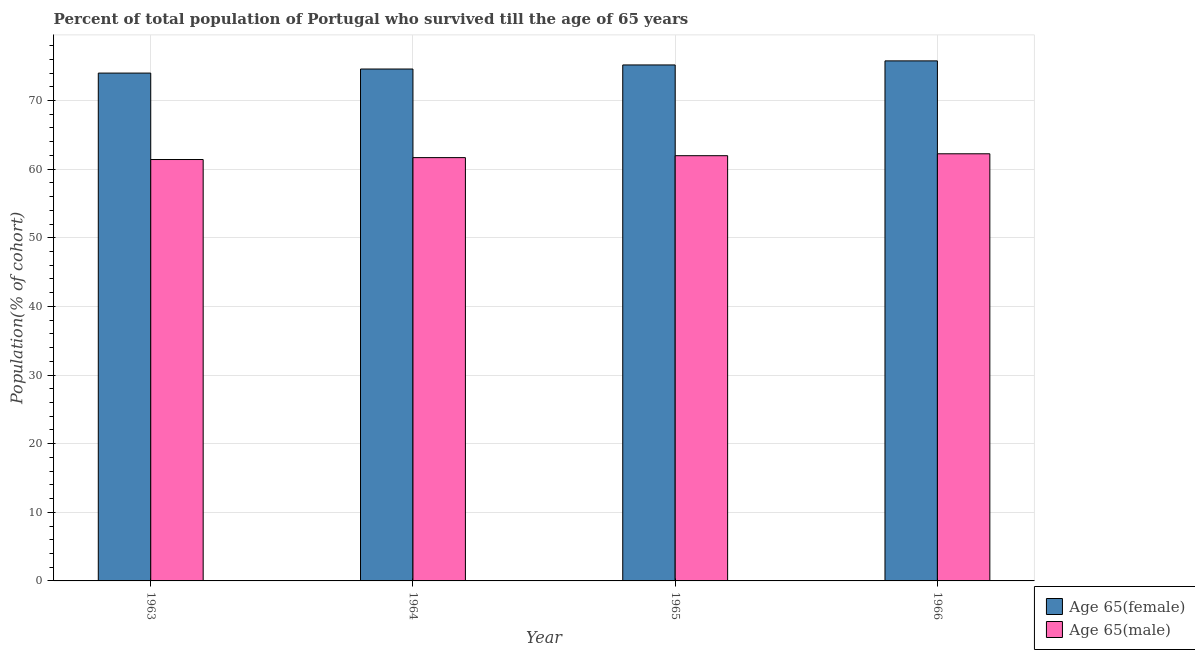How many different coloured bars are there?
Provide a short and direct response. 2. How many groups of bars are there?
Provide a short and direct response. 4. How many bars are there on the 4th tick from the left?
Offer a terse response. 2. How many bars are there on the 4th tick from the right?
Offer a very short reply. 2. What is the label of the 4th group of bars from the left?
Your response must be concise. 1966. In how many cases, is the number of bars for a given year not equal to the number of legend labels?
Offer a very short reply. 0. What is the percentage of male population who survived till age of 65 in 1963?
Ensure brevity in your answer.  61.4. Across all years, what is the maximum percentage of female population who survived till age of 65?
Provide a short and direct response. 75.77. Across all years, what is the minimum percentage of male population who survived till age of 65?
Ensure brevity in your answer.  61.4. In which year was the percentage of female population who survived till age of 65 maximum?
Offer a very short reply. 1966. In which year was the percentage of male population who survived till age of 65 minimum?
Ensure brevity in your answer.  1963. What is the total percentage of female population who survived till age of 65 in the graph?
Make the answer very short. 299.53. What is the difference between the percentage of female population who survived till age of 65 in 1963 and that in 1966?
Your answer should be compact. -1.78. What is the difference between the percentage of female population who survived till age of 65 in 1965 and the percentage of male population who survived till age of 65 in 1964?
Your answer should be compact. 0.59. What is the average percentage of female population who survived till age of 65 per year?
Offer a very short reply. 74.88. What is the ratio of the percentage of male population who survived till age of 65 in 1963 to that in 1966?
Offer a terse response. 0.99. Is the difference between the percentage of female population who survived till age of 65 in 1964 and 1966 greater than the difference between the percentage of male population who survived till age of 65 in 1964 and 1966?
Provide a succinct answer. No. What is the difference between the highest and the second highest percentage of male population who survived till age of 65?
Your answer should be compact. 0.28. What is the difference between the highest and the lowest percentage of female population who survived till age of 65?
Make the answer very short. 1.78. Is the sum of the percentage of female population who survived till age of 65 in 1963 and 1965 greater than the maximum percentage of male population who survived till age of 65 across all years?
Your response must be concise. Yes. What does the 1st bar from the left in 1964 represents?
Your answer should be compact. Age 65(female). What does the 1st bar from the right in 1964 represents?
Provide a short and direct response. Age 65(male). How many bars are there?
Offer a terse response. 8. Are all the bars in the graph horizontal?
Your response must be concise. No. What is the difference between two consecutive major ticks on the Y-axis?
Provide a succinct answer. 10. Are the values on the major ticks of Y-axis written in scientific E-notation?
Offer a terse response. No. Where does the legend appear in the graph?
Provide a succinct answer. Bottom right. How are the legend labels stacked?
Keep it short and to the point. Vertical. What is the title of the graph?
Keep it short and to the point. Percent of total population of Portugal who survived till the age of 65 years. Does "IMF concessional" appear as one of the legend labels in the graph?
Offer a terse response. No. What is the label or title of the Y-axis?
Provide a short and direct response. Population(% of cohort). What is the Population(% of cohort) in Age 65(female) in 1963?
Provide a short and direct response. 73.99. What is the Population(% of cohort) of Age 65(male) in 1963?
Provide a short and direct response. 61.4. What is the Population(% of cohort) in Age 65(female) in 1964?
Make the answer very short. 74.59. What is the Population(% of cohort) of Age 65(male) in 1964?
Provide a succinct answer. 61.68. What is the Population(% of cohort) in Age 65(female) in 1965?
Keep it short and to the point. 75.18. What is the Population(% of cohort) in Age 65(male) in 1965?
Your answer should be very brief. 61.96. What is the Population(% of cohort) of Age 65(female) in 1966?
Your answer should be compact. 75.77. What is the Population(% of cohort) in Age 65(male) in 1966?
Make the answer very short. 62.24. Across all years, what is the maximum Population(% of cohort) of Age 65(female)?
Make the answer very short. 75.77. Across all years, what is the maximum Population(% of cohort) of Age 65(male)?
Offer a terse response. 62.24. Across all years, what is the minimum Population(% of cohort) of Age 65(female)?
Provide a succinct answer. 73.99. Across all years, what is the minimum Population(% of cohort) in Age 65(male)?
Your answer should be very brief. 61.4. What is the total Population(% of cohort) of Age 65(female) in the graph?
Provide a short and direct response. 299.53. What is the total Population(% of cohort) of Age 65(male) in the graph?
Keep it short and to the point. 247.27. What is the difference between the Population(% of cohort) of Age 65(female) in 1963 and that in 1964?
Keep it short and to the point. -0.59. What is the difference between the Population(% of cohort) of Age 65(male) in 1963 and that in 1964?
Your answer should be compact. -0.28. What is the difference between the Population(% of cohort) of Age 65(female) in 1963 and that in 1965?
Your answer should be very brief. -1.19. What is the difference between the Population(% of cohort) of Age 65(male) in 1963 and that in 1965?
Provide a short and direct response. -0.56. What is the difference between the Population(% of cohort) in Age 65(female) in 1963 and that in 1966?
Your answer should be very brief. -1.78. What is the difference between the Population(% of cohort) in Age 65(male) in 1963 and that in 1966?
Make the answer very short. -0.84. What is the difference between the Population(% of cohort) of Age 65(female) in 1964 and that in 1965?
Make the answer very short. -0.59. What is the difference between the Population(% of cohort) of Age 65(male) in 1964 and that in 1965?
Your answer should be very brief. -0.28. What is the difference between the Population(% of cohort) of Age 65(female) in 1964 and that in 1966?
Ensure brevity in your answer.  -1.19. What is the difference between the Population(% of cohort) in Age 65(male) in 1964 and that in 1966?
Make the answer very short. -0.56. What is the difference between the Population(% of cohort) in Age 65(female) in 1965 and that in 1966?
Your answer should be very brief. -0.59. What is the difference between the Population(% of cohort) of Age 65(male) in 1965 and that in 1966?
Provide a succinct answer. -0.28. What is the difference between the Population(% of cohort) in Age 65(female) in 1963 and the Population(% of cohort) in Age 65(male) in 1964?
Offer a terse response. 12.32. What is the difference between the Population(% of cohort) of Age 65(female) in 1963 and the Population(% of cohort) of Age 65(male) in 1965?
Provide a succinct answer. 12.04. What is the difference between the Population(% of cohort) in Age 65(female) in 1963 and the Population(% of cohort) in Age 65(male) in 1966?
Provide a succinct answer. 11.76. What is the difference between the Population(% of cohort) of Age 65(female) in 1964 and the Population(% of cohort) of Age 65(male) in 1965?
Provide a succinct answer. 12.63. What is the difference between the Population(% of cohort) in Age 65(female) in 1964 and the Population(% of cohort) in Age 65(male) in 1966?
Make the answer very short. 12.35. What is the difference between the Population(% of cohort) in Age 65(female) in 1965 and the Population(% of cohort) in Age 65(male) in 1966?
Provide a short and direct response. 12.94. What is the average Population(% of cohort) of Age 65(female) per year?
Your answer should be very brief. 74.88. What is the average Population(% of cohort) in Age 65(male) per year?
Provide a succinct answer. 61.82. In the year 1963, what is the difference between the Population(% of cohort) of Age 65(female) and Population(% of cohort) of Age 65(male)?
Your response must be concise. 12.59. In the year 1964, what is the difference between the Population(% of cohort) in Age 65(female) and Population(% of cohort) in Age 65(male)?
Offer a very short reply. 12.91. In the year 1965, what is the difference between the Population(% of cohort) in Age 65(female) and Population(% of cohort) in Age 65(male)?
Your answer should be very brief. 13.22. In the year 1966, what is the difference between the Population(% of cohort) in Age 65(female) and Population(% of cohort) in Age 65(male)?
Ensure brevity in your answer.  13.54. What is the ratio of the Population(% of cohort) in Age 65(female) in 1963 to that in 1964?
Provide a short and direct response. 0.99. What is the ratio of the Population(% of cohort) of Age 65(female) in 1963 to that in 1965?
Ensure brevity in your answer.  0.98. What is the ratio of the Population(% of cohort) in Age 65(female) in 1963 to that in 1966?
Your response must be concise. 0.98. What is the ratio of the Population(% of cohort) in Age 65(male) in 1963 to that in 1966?
Give a very brief answer. 0.99. What is the ratio of the Population(% of cohort) in Age 65(female) in 1964 to that in 1966?
Make the answer very short. 0.98. What is the ratio of the Population(% of cohort) in Age 65(female) in 1965 to that in 1966?
Your answer should be compact. 0.99. What is the ratio of the Population(% of cohort) in Age 65(male) in 1965 to that in 1966?
Make the answer very short. 1. What is the difference between the highest and the second highest Population(% of cohort) of Age 65(female)?
Your response must be concise. 0.59. What is the difference between the highest and the second highest Population(% of cohort) in Age 65(male)?
Ensure brevity in your answer.  0.28. What is the difference between the highest and the lowest Population(% of cohort) in Age 65(female)?
Your response must be concise. 1.78. What is the difference between the highest and the lowest Population(% of cohort) in Age 65(male)?
Offer a terse response. 0.84. 